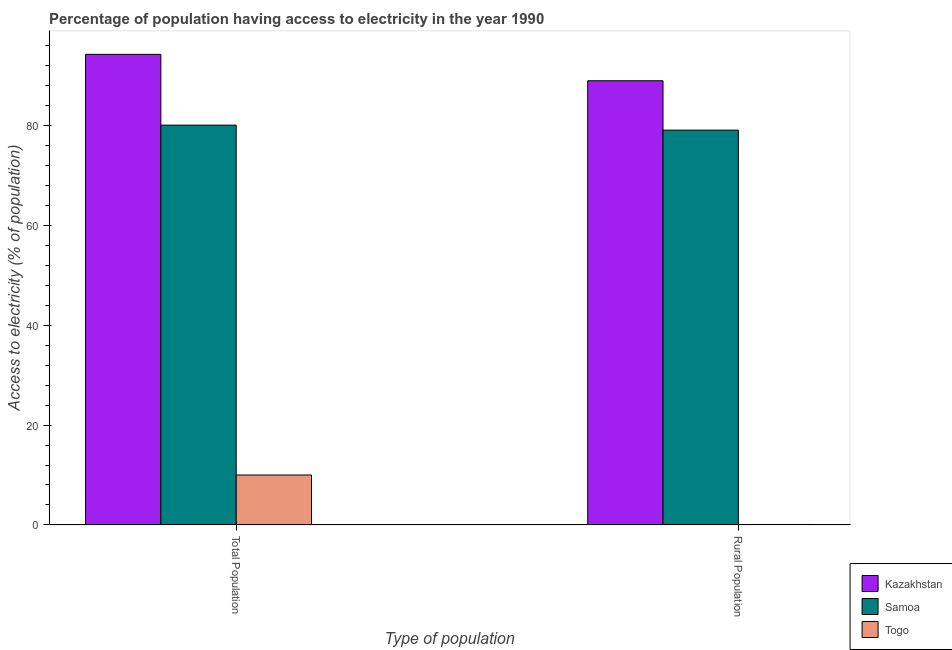How many groups of bars are there?
Ensure brevity in your answer.  2. Are the number of bars on each tick of the X-axis equal?
Your answer should be compact. Yes. What is the label of the 2nd group of bars from the left?
Provide a succinct answer. Rural Population. What is the percentage of population having access to electricity in Samoa?
Offer a very short reply. 80. Across all countries, what is the maximum percentage of population having access to electricity?
Provide a short and direct response. 94.16. Across all countries, what is the minimum percentage of population having access to electricity?
Your answer should be compact. 10. In which country was the percentage of rural population having access to electricity maximum?
Keep it short and to the point. Kazakhstan. In which country was the percentage of rural population having access to electricity minimum?
Offer a very short reply. Togo. What is the total percentage of rural population having access to electricity in the graph?
Your response must be concise. 167.98. What is the difference between the percentage of population having access to electricity in Kazakhstan and that in Togo?
Give a very brief answer. 84.16. What is the difference between the percentage of rural population having access to electricity in Togo and the percentage of population having access to electricity in Samoa?
Provide a succinct answer. -79.9. What is the average percentage of population having access to electricity per country?
Offer a very short reply. 61.39. What is the ratio of the percentage of population having access to electricity in Togo to that in Kazakhstan?
Give a very brief answer. 0.11. In how many countries, is the percentage of population having access to electricity greater than the average percentage of population having access to electricity taken over all countries?
Ensure brevity in your answer.  2. What does the 3rd bar from the left in Total Population represents?
Your answer should be compact. Togo. What does the 1st bar from the right in Total Population represents?
Your response must be concise. Togo. How many bars are there?
Give a very brief answer. 6. Are the values on the major ticks of Y-axis written in scientific E-notation?
Offer a very short reply. No. Does the graph contain any zero values?
Your answer should be very brief. No. How are the legend labels stacked?
Give a very brief answer. Vertical. What is the title of the graph?
Keep it short and to the point. Percentage of population having access to electricity in the year 1990. Does "Comoros" appear as one of the legend labels in the graph?
Ensure brevity in your answer.  No. What is the label or title of the X-axis?
Your answer should be very brief. Type of population. What is the label or title of the Y-axis?
Your answer should be very brief. Access to electricity (% of population). What is the Access to electricity (% of population) in Kazakhstan in Total Population?
Keep it short and to the point. 94.16. What is the Access to electricity (% of population) of Samoa in Total Population?
Provide a short and direct response. 80. What is the Access to electricity (% of population) of Kazakhstan in Rural Population?
Keep it short and to the point. 88.88. What is the Access to electricity (% of population) of Samoa in Rural Population?
Keep it short and to the point. 79. What is the Access to electricity (% of population) of Togo in Rural Population?
Your response must be concise. 0.1. Across all Type of population, what is the maximum Access to electricity (% of population) of Kazakhstan?
Keep it short and to the point. 94.16. Across all Type of population, what is the maximum Access to electricity (% of population) of Samoa?
Your answer should be very brief. 80. Across all Type of population, what is the maximum Access to electricity (% of population) of Togo?
Your answer should be very brief. 10. Across all Type of population, what is the minimum Access to electricity (% of population) in Kazakhstan?
Offer a terse response. 88.88. Across all Type of population, what is the minimum Access to electricity (% of population) in Samoa?
Ensure brevity in your answer.  79. What is the total Access to electricity (% of population) of Kazakhstan in the graph?
Make the answer very short. 183.04. What is the total Access to electricity (% of population) in Samoa in the graph?
Your answer should be very brief. 159. What is the difference between the Access to electricity (% of population) of Kazakhstan in Total Population and that in Rural Population?
Give a very brief answer. 5.28. What is the difference between the Access to electricity (% of population) in Kazakhstan in Total Population and the Access to electricity (% of population) in Samoa in Rural Population?
Provide a succinct answer. 15.16. What is the difference between the Access to electricity (% of population) of Kazakhstan in Total Population and the Access to electricity (% of population) of Togo in Rural Population?
Provide a short and direct response. 94.06. What is the difference between the Access to electricity (% of population) in Samoa in Total Population and the Access to electricity (% of population) in Togo in Rural Population?
Keep it short and to the point. 79.9. What is the average Access to electricity (% of population) of Kazakhstan per Type of population?
Your answer should be compact. 91.52. What is the average Access to electricity (% of population) in Samoa per Type of population?
Your answer should be compact. 79.5. What is the average Access to electricity (% of population) of Togo per Type of population?
Provide a succinct answer. 5.05. What is the difference between the Access to electricity (% of population) in Kazakhstan and Access to electricity (% of population) in Samoa in Total Population?
Offer a very short reply. 14.16. What is the difference between the Access to electricity (% of population) in Kazakhstan and Access to electricity (% of population) in Togo in Total Population?
Ensure brevity in your answer.  84.16. What is the difference between the Access to electricity (% of population) of Kazakhstan and Access to electricity (% of population) of Samoa in Rural Population?
Provide a short and direct response. 9.88. What is the difference between the Access to electricity (% of population) of Kazakhstan and Access to electricity (% of population) of Togo in Rural Population?
Your answer should be compact. 88.78. What is the difference between the Access to electricity (% of population) in Samoa and Access to electricity (% of population) in Togo in Rural Population?
Your response must be concise. 78.9. What is the ratio of the Access to electricity (% of population) of Kazakhstan in Total Population to that in Rural Population?
Make the answer very short. 1.06. What is the ratio of the Access to electricity (% of population) in Samoa in Total Population to that in Rural Population?
Give a very brief answer. 1.01. What is the ratio of the Access to electricity (% of population) of Togo in Total Population to that in Rural Population?
Offer a terse response. 100. What is the difference between the highest and the second highest Access to electricity (% of population) of Kazakhstan?
Your response must be concise. 5.28. What is the difference between the highest and the second highest Access to electricity (% of population) of Samoa?
Ensure brevity in your answer.  1. What is the difference between the highest and the lowest Access to electricity (% of population) of Kazakhstan?
Keep it short and to the point. 5.28. What is the difference between the highest and the lowest Access to electricity (% of population) in Samoa?
Offer a very short reply. 1. What is the difference between the highest and the lowest Access to electricity (% of population) in Togo?
Keep it short and to the point. 9.9. 